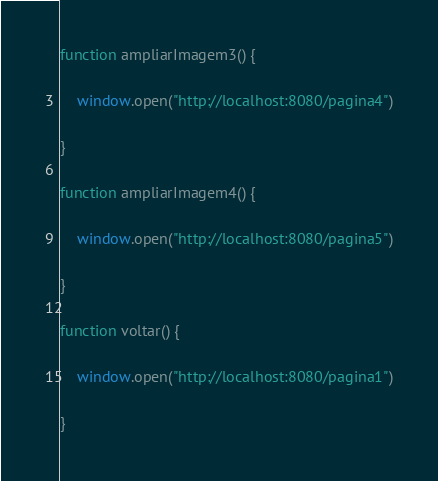<code> <loc_0><loc_0><loc_500><loc_500><_JavaScript_>function ampliarImagem3() {

    window.open("http://localhost:8080/pagina4")

}

function ampliarImagem4() {

    window.open("http://localhost:8080/pagina5")

}

function voltar() {

    window.open("http://localhost:8080/pagina1")

}</code> 